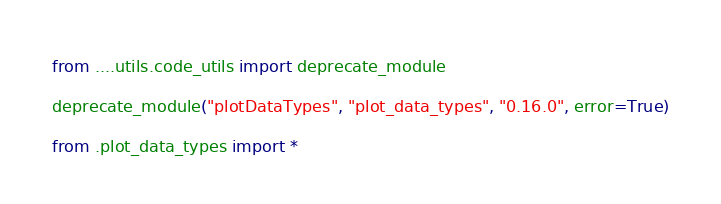<code> <loc_0><loc_0><loc_500><loc_500><_Python_>from ....utils.code_utils import deprecate_module

deprecate_module("plotDataTypes", "plot_data_types", "0.16.0", error=True)

from .plot_data_types import *
</code> 